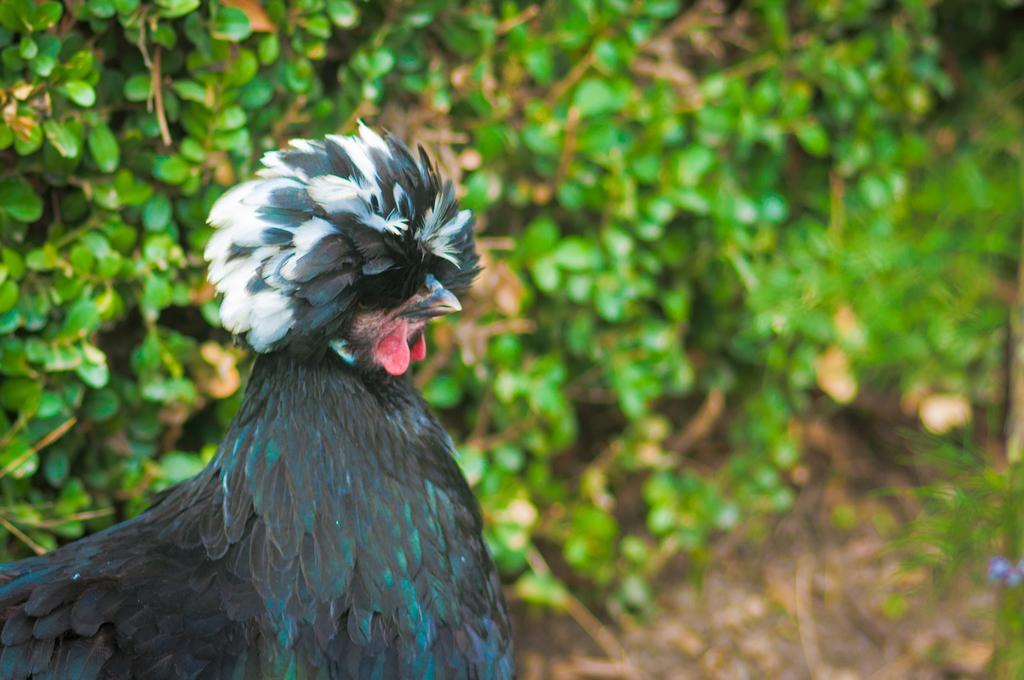Can you describe this image briefly? In this picture there is a hen on the left side of the image and there is greenery in the background area of the image. 